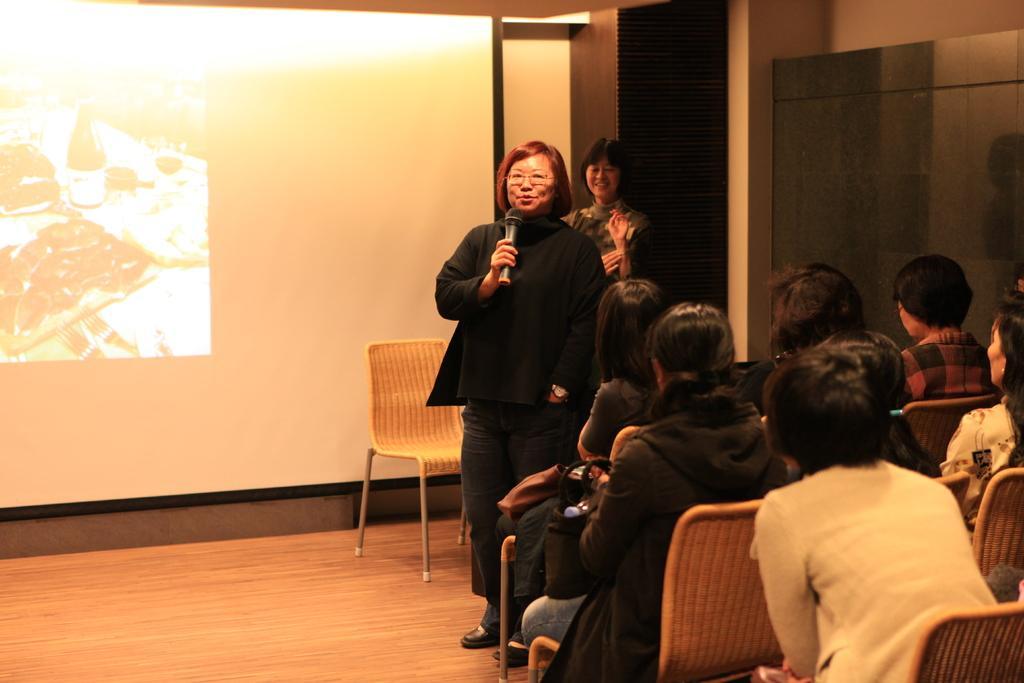Describe this image in one or two sentences. Here we can see some persons are sitting on the chairs. There is a woman who is talking on the mike. This is floor and there is a screen. 